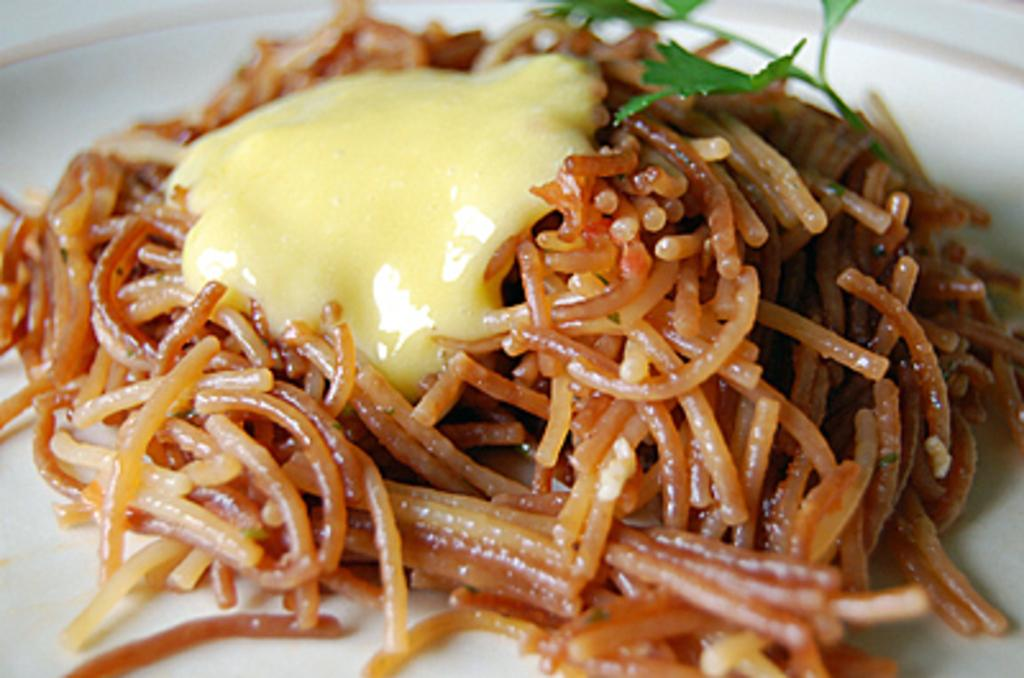What is present on the plate in the image? There is a plate of food item in the image. What type of sheet is being used to clean the street in the image? There is no sheet or street present in the image; it only features a plate of food item. 